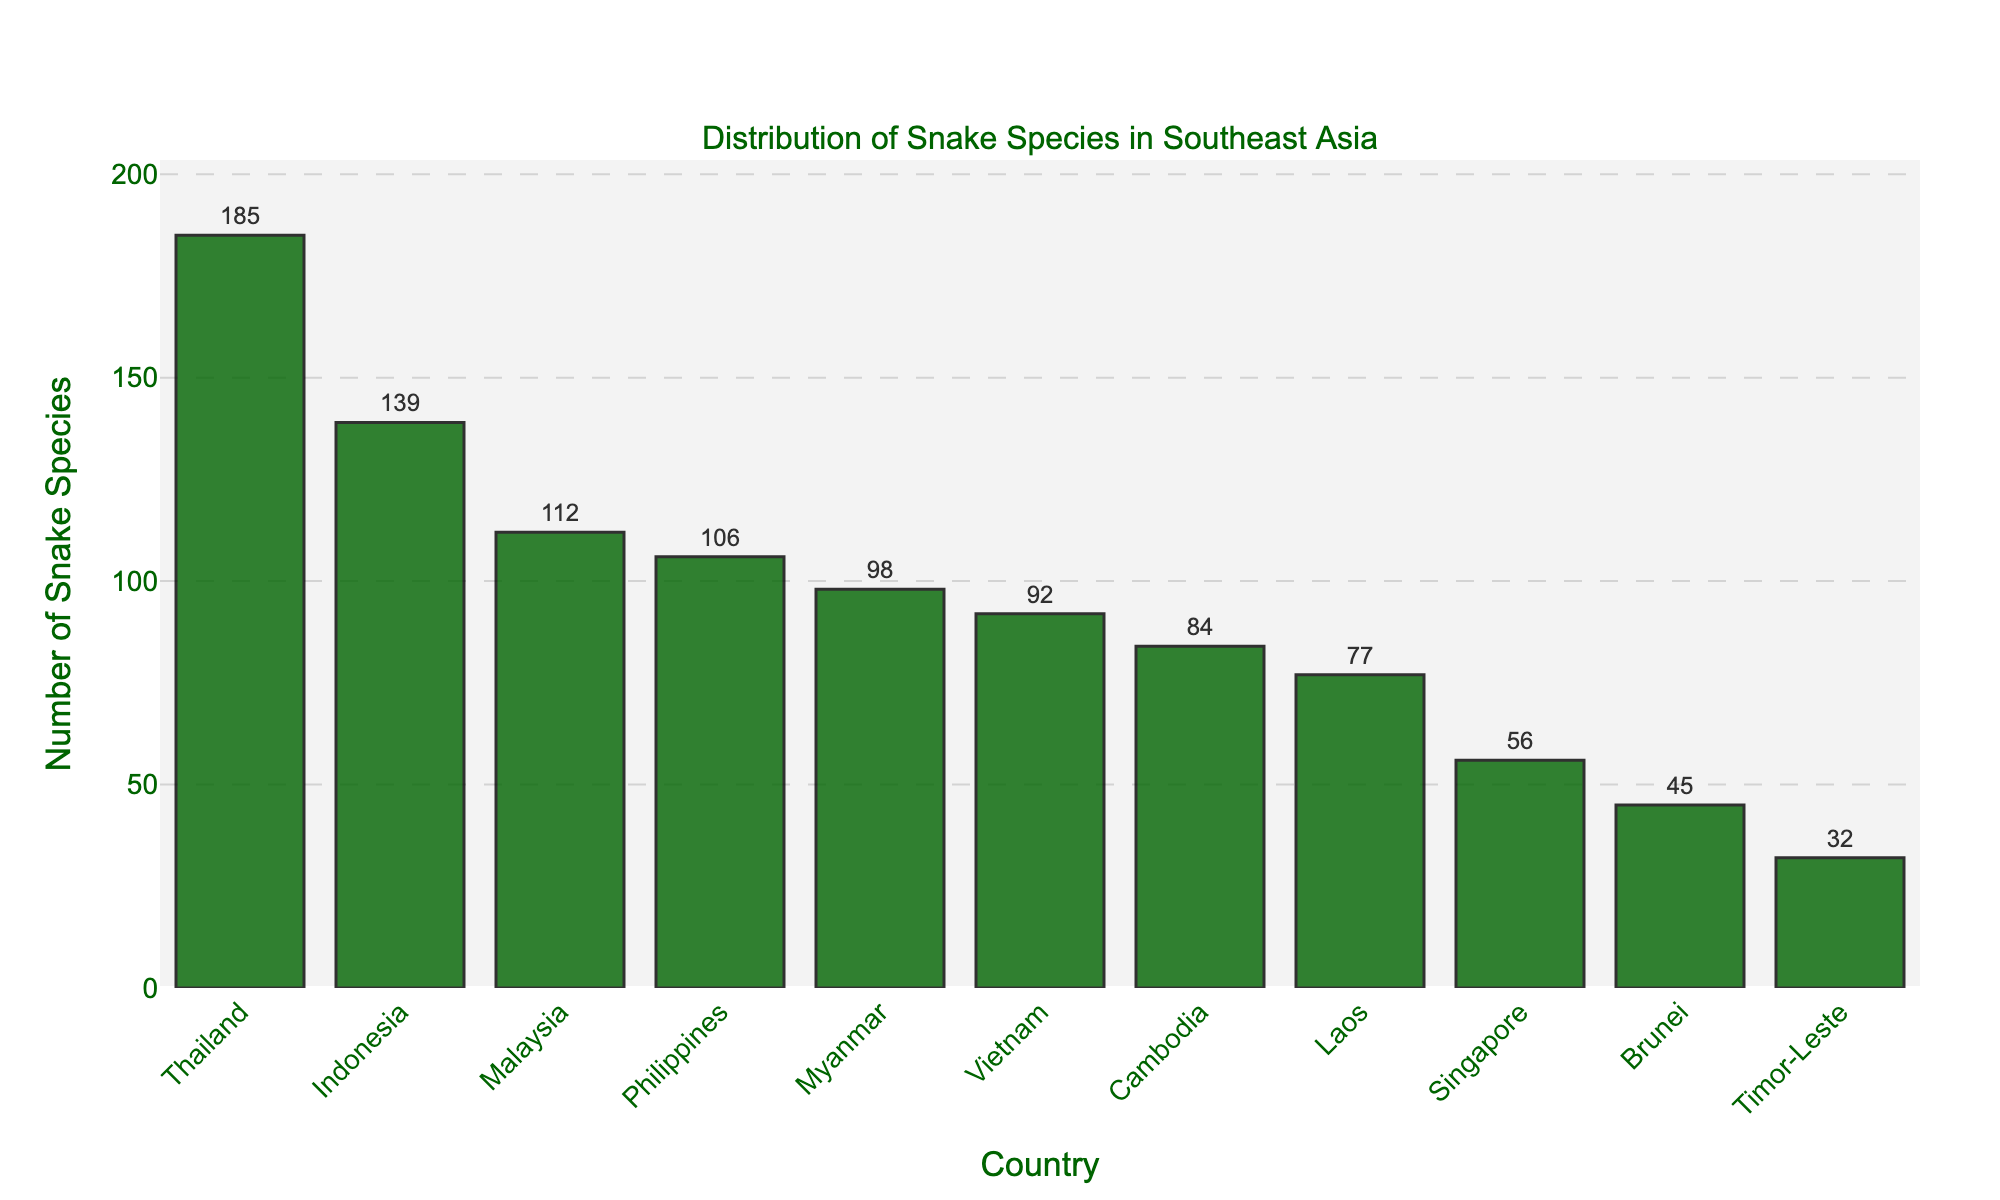Which country has the highest number of snake species? The country with the highest bar represents the highest number of snake species. In this case, Thailand's bar is the tallest.
Answer: Thailand Which country has the lowest number of snake species? The country with the shortest bar represents the lowest number of snake species. In this chart, Timor-Leste's bar is the shortest.
Answer: Timor-Leste What is the total number of snake species in Indonesia and Malaysia combined? Add the number of snake species from Indonesia and Malaysia: 139 (Indonesia) + 112 (Malaysia) = 251
Answer: 251 Which countries have fewer than 50 snake species? Identify the countries where the bar length corresponds to fewer than 50. In this chart, they are Brunei and Timor-Leste.
Answer: Brunei, Timor-Leste How many more snake species does Thailand have compared to Vietnam? Subtract the number of snake species in Vietnam from the number in Thailand: 185 (Thailand) - 92 (Vietnam) = 93
Answer: 93 What is the average number of snake species across all listed countries? Sum the number of snake species for all countries and divide by the number of countries: (185 + 139 + 112 + 106 + 98 + 92 + 84 + 77 + 56 + 45 + 32) / 11 = 102.7
Answer: 102.7 Which country ranks second in the number of snake species? Identify the country with the bar that is the second tallest. In this chart, Indonesia has the second tallest bar after Thailand.
Answer: Indonesia What’s the range of the number of snake species across these Southeast Asian countries? Subtract the smallest number of snake species from the largest: 185 (Thailand) - 32 (Timor-Leste) = 153
Answer: 153 How does the number of snake species in Cambodia compare to that in Laos? Compare the heights of the bars for Cambodia and Laos. The bar for Cambodia is taller than that for Laos, indicating it has more snake species.
Answer: Cambodia has more Approximately what fraction of the total number of snake species does Singapore have? Divide the number of snake species in Singapore by the total number of snake species across all countries and simplify the fraction: 56 / (185 + 139 + 112 + 106 + 98 + 92 + 84 + 77 + 56 + 45 + 32) ≈ 56 / 1132 ≈ 1/20
Answer: 1/20 